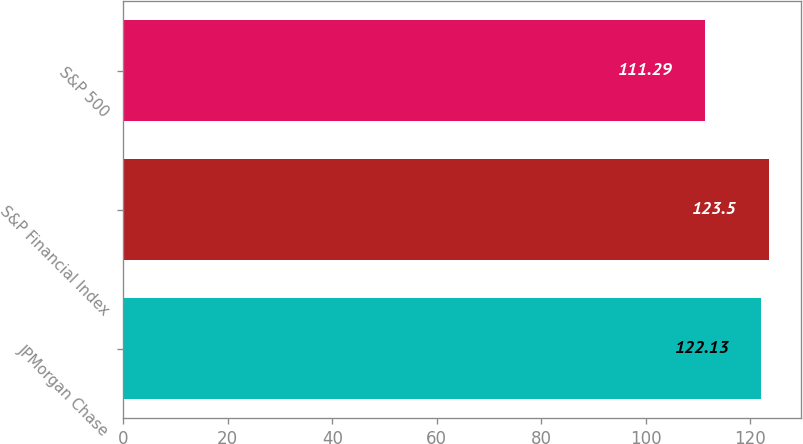<chart> <loc_0><loc_0><loc_500><loc_500><bar_chart><fcel>JPMorgan Chase<fcel>S&P Financial Index<fcel>S&P 500<nl><fcel>122.13<fcel>123.5<fcel>111.29<nl></chart> 